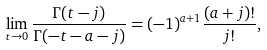<formula> <loc_0><loc_0><loc_500><loc_500>\lim _ { t \to 0 } \frac { \Gamma ( t - j ) } { \Gamma ( - t - a - j ) } = ( - 1 ) ^ { a + 1 } \frac { ( a + j ) ! } { j ! } ,</formula> 